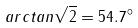<formula> <loc_0><loc_0><loc_500><loc_500>a r c t a n \sqrt { 2 } = 5 4 . 7 ^ { \circ }</formula> 